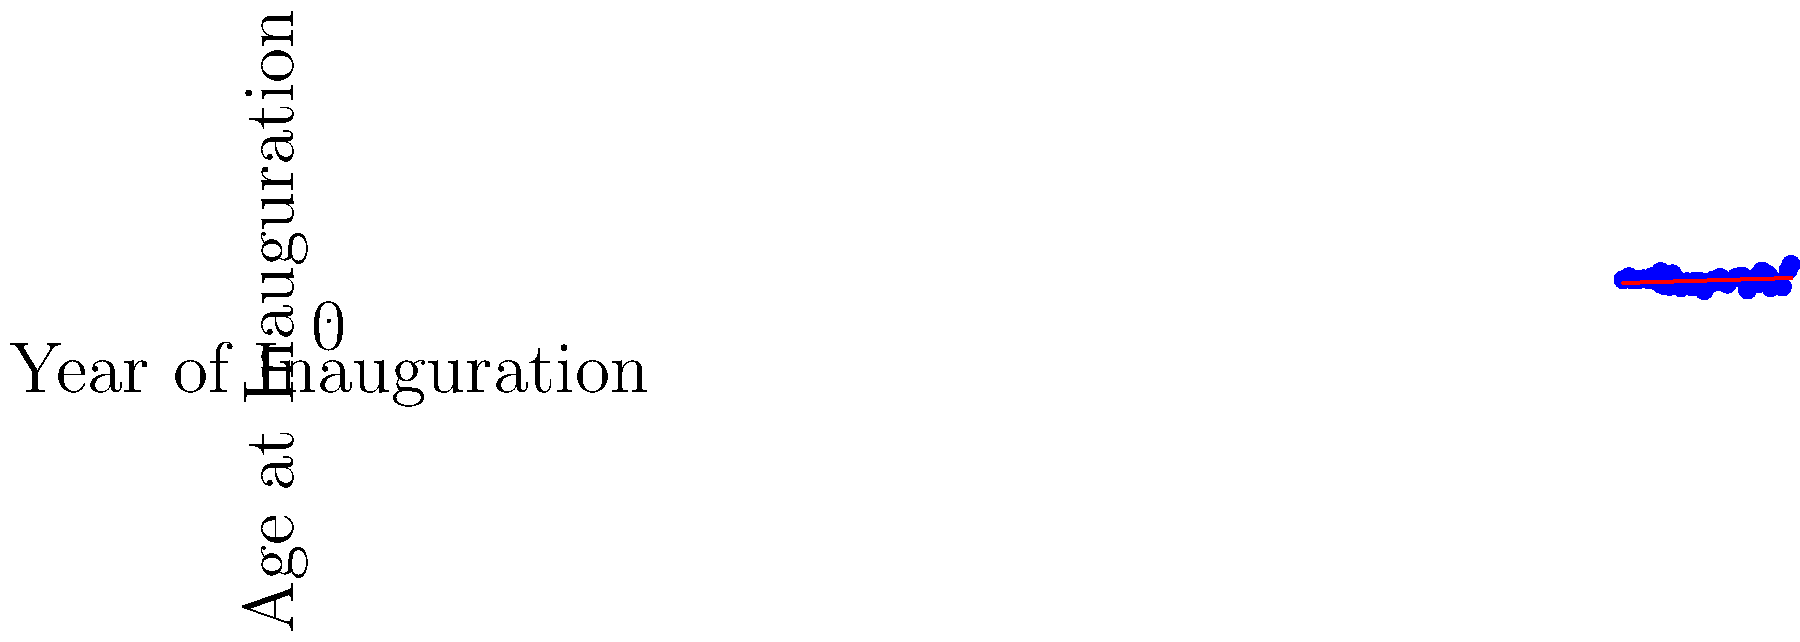Based on the scatter plot showing the age at inauguration for each U.S. president, what trend can be observed in the relationship between the year of inauguration and the age of presidents when they took office? To determine the trend in the relationship between the year of inauguration and the age of presidents at inauguration, we need to analyze the scatter plot:

1. Observe the overall pattern of the data points:
   - The points seem to have a slight upward trend from left to right.

2. Look at the red trend line:
   - The trend line is sloping upward, which confirms the visual observation.

3. Analyze the earliest and latest data points:
   - The earliest presidents (left side of the plot) tend to cluster around ages 50-60.
   - The most recent presidents (right side of the plot) show more variation, but include some of the oldest presidents.

4. Note outliers and exceptions:
   - There are some notably young presidents (points at the bottom) throughout history.
   - The highest point on the right represents the oldest president at inauguration.

5. Consider the overall trend:
   - Despite fluctuations, there is a general increase in age over time.
   - The trend line suggests a gradual increase in the average age of presidents at inauguration as years progress.

Based on these observations, we can conclude that there is a slight upward trend in the age of U.S. presidents at inauguration over time.
Answer: Slight upward trend in presidential age at inauguration over time. 